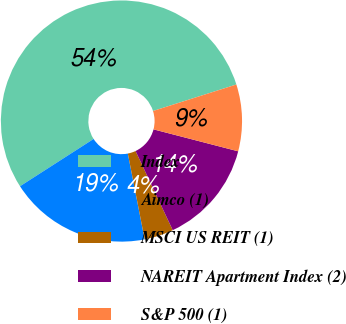<chart> <loc_0><loc_0><loc_500><loc_500><pie_chart><fcel>Index<fcel>Aimco (1)<fcel>MSCI US REIT (1)<fcel>NAREIT Apartment Index (2)<fcel>S&P 500 (1)<nl><fcel>54.19%<fcel>18.99%<fcel>3.91%<fcel>13.97%<fcel>8.94%<nl></chart> 